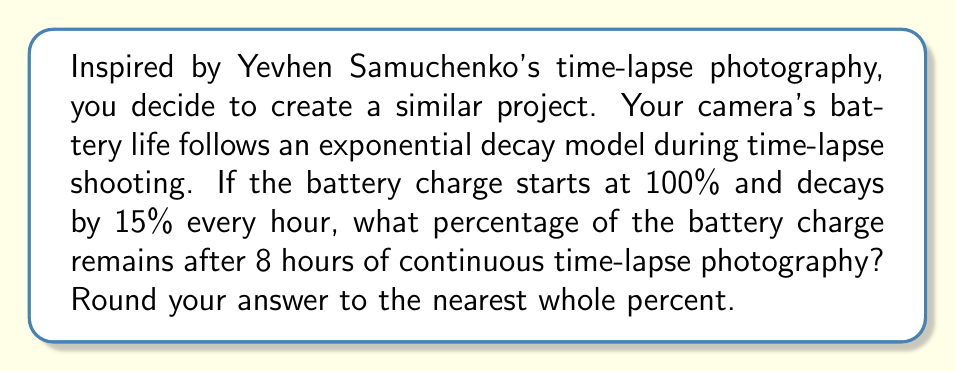Teach me how to tackle this problem. Let's approach this step-by-step:

1) The exponential decay formula is:
   $$A(t) = A_0 \cdot (1-r)^t$$
   Where:
   $A(t)$ is the amount remaining after time $t$
   $A_0$ is the initial amount
   $r$ is the decay rate per unit time
   $t$ is the time elapsed

2) In this problem:
   $A_0 = 100\%$ (initial charge)
   $r = 15\% = 0.15$ (decay rate per hour)
   $t = 8$ hours

3) Plugging these values into the formula:
   $$A(8) = 100 \cdot (1-0.15)^8$$

4) Simplify:
   $$A(8) = 100 \cdot (0.85)^8$$

5) Calculate:
   $$A(8) = 100 \cdot 0.2725$$
   $$A(8) = 27.25\%$$

6) Rounding to the nearest whole percent:
   $$A(8) \approx 27\%$$
Answer: 27% 